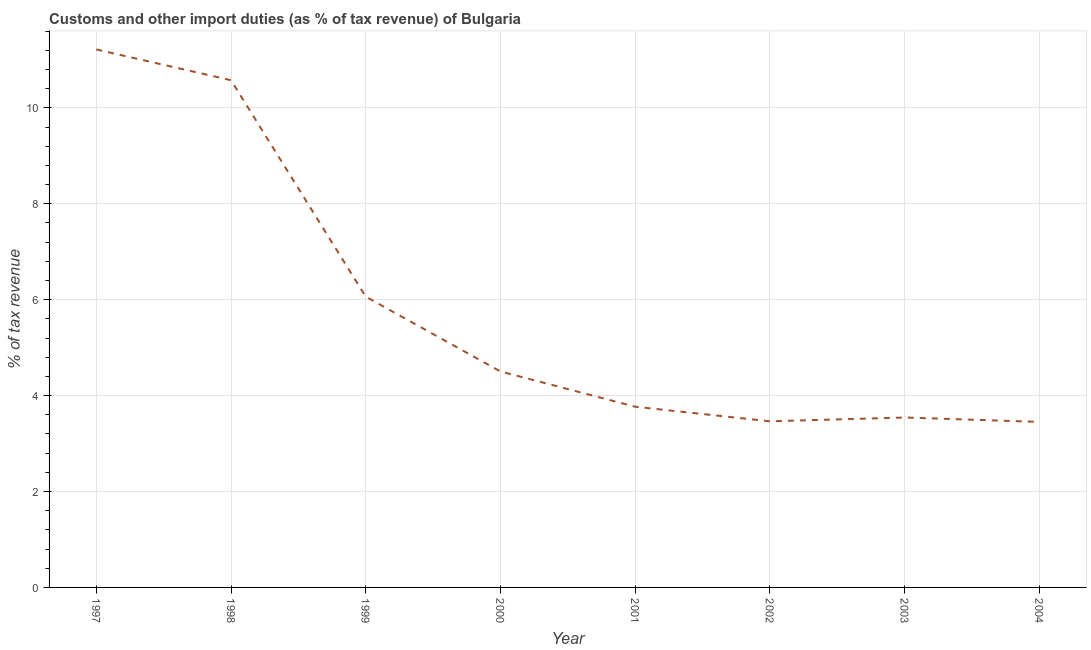What is the customs and other import duties in 2002?
Give a very brief answer. 3.46. Across all years, what is the maximum customs and other import duties?
Your response must be concise. 11.22. Across all years, what is the minimum customs and other import duties?
Your answer should be very brief. 3.45. In which year was the customs and other import duties maximum?
Your answer should be very brief. 1997. What is the sum of the customs and other import duties?
Give a very brief answer. 46.59. What is the difference between the customs and other import duties in 1997 and 2000?
Give a very brief answer. 6.71. What is the average customs and other import duties per year?
Provide a short and direct response. 5.82. What is the median customs and other import duties?
Provide a short and direct response. 4.14. In how many years, is the customs and other import duties greater than 10.8 %?
Offer a terse response. 1. Do a majority of the years between 1999 and 1997 (inclusive) have customs and other import duties greater than 2.4 %?
Make the answer very short. No. What is the ratio of the customs and other import duties in 1997 to that in 2002?
Provide a short and direct response. 3.24. Is the customs and other import duties in 1999 less than that in 2000?
Your answer should be compact. No. What is the difference between the highest and the second highest customs and other import duties?
Keep it short and to the point. 0.64. Is the sum of the customs and other import duties in 2001 and 2002 greater than the maximum customs and other import duties across all years?
Offer a terse response. No. What is the difference between the highest and the lowest customs and other import duties?
Your response must be concise. 7.77. Does the customs and other import duties monotonically increase over the years?
Provide a short and direct response. No. How many lines are there?
Your answer should be compact. 1. Are the values on the major ticks of Y-axis written in scientific E-notation?
Ensure brevity in your answer.  No. Does the graph contain grids?
Give a very brief answer. Yes. What is the title of the graph?
Offer a very short reply. Customs and other import duties (as % of tax revenue) of Bulgaria. What is the label or title of the X-axis?
Your answer should be compact. Year. What is the label or title of the Y-axis?
Your answer should be very brief. % of tax revenue. What is the % of tax revenue of 1997?
Offer a very short reply. 11.22. What is the % of tax revenue of 1998?
Give a very brief answer. 10.58. What is the % of tax revenue in 1999?
Make the answer very short. 6.06. What is the % of tax revenue in 2000?
Provide a short and direct response. 4.5. What is the % of tax revenue of 2001?
Provide a succinct answer. 3.77. What is the % of tax revenue of 2002?
Your answer should be very brief. 3.46. What is the % of tax revenue in 2003?
Make the answer very short. 3.54. What is the % of tax revenue in 2004?
Provide a succinct answer. 3.45. What is the difference between the % of tax revenue in 1997 and 1998?
Keep it short and to the point. 0.64. What is the difference between the % of tax revenue in 1997 and 1999?
Your answer should be compact. 5.16. What is the difference between the % of tax revenue in 1997 and 2000?
Offer a very short reply. 6.71. What is the difference between the % of tax revenue in 1997 and 2001?
Ensure brevity in your answer.  7.45. What is the difference between the % of tax revenue in 1997 and 2002?
Your response must be concise. 7.75. What is the difference between the % of tax revenue in 1997 and 2003?
Your answer should be very brief. 7.67. What is the difference between the % of tax revenue in 1997 and 2004?
Your answer should be compact. 7.77. What is the difference between the % of tax revenue in 1998 and 1999?
Offer a terse response. 4.51. What is the difference between the % of tax revenue in 1998 and 2000?
Provide a succinct answer. 6.07. What is the difference between the % of tax revenue in 1998 and 2001?
Give a very brief answer. 6.81. What is the difference between the % of tax revenue in 1998 and 2002?
Your response must be concise. 7.11. What is the difference between the % of tax revenue in 1998 and 2003?
Offer a terse response. 7.03. What is the difference between the % of tax revenue in 1998 and 2004?
Your answer should be very brief. 7.12. What is the difference between the % of tax revenue in 1999 and 2000?
Offer a very short reply. 1.56. What is the difference between the % of tax revenue in 1999 and 2001?
Provide a short and direct response. 2.29. What is the difference between the % of tax revenue in 1999 and 2002?
Keep it short and to the point. 2.6. What is the difference between the % of tax revenue in 1999 and 2003?
Offer a terse response. 2.52. What is the difference between the % of tax revenue in 1999 and 2004?
Make the answer very short. 2.61. What is the difference between the % of tax revenue in 2000 and 2001?
Provide a succinct answer. 0.74. What is the difference between the % of tax revenue in 2000 and 2002?
Offer a terse response. 1.04. What is the difference between the % of tax revenue in 2000 and 2003?
Offer a terse response. 0.96. What is the difference between the % of tax revenue in 2000 and 2004?
Keep it short and to the point. 1.05. What is the difference between the % of tax revenue in 2001 and 2002?
Your answer should be compact. 0.3. What is the difference between the % of tax revenue in 2001 and 2003?
Provide a succinct answer. 0.23. What is the difference between the % of tax revenue in 2001 and 2004?
Provide a short and direct response. 0.32. What is the difference between the % of tax revenue in 2002 and 2003?
Provide a succinct answer. -0.08. What is the difference between the % of tax revenue in 2002 and 2004?
Your answer should be compact. 0.01. What is the difference between the % of tax revenue in 2003 and 2004?
Give a very brief answer. 0.09. What is the ratio of the % of tax revenue in 1997 to that in 1998?
Offer a terse response. 1.06. What is the ratio of the % of tax revenue in 1997 to that in 1999?
Provide a short and direct response. 1.85. What is the ratio of the % of tax revenue in 1997 to that in 2000?
Keep it short and to the point. 2.49. What is the ratio of the % of tax revenue in 1997 to that in 2001?
Provide a short and direct response. 2.98. What is the ratio of the % of tax revenue in 1997 to that in 2002?
Provide a succinct answer. 3.24. What is the ratio of the % of tax revenue in 1997 to that in 2003?
Your response must be concise. 3.17. What is the ratio of the % of tax revenue in 1998 to that in 1999?
Provide a short and direct response. 1.74. What is the ratio of the % of tax revenue in 1998 to that in 2000?
Keep it short and to the point. 2.35. What is the ratio of the % of tax revenue in 1998 to that in 2001?
Provide a succinct answer. 2.81. What is the ratio of the % of tax revenue in 1998 to that in 2002?
Give a very brief answer. 3.05. What is the ratio of the % of tax revenue in 1998 to that in 2003?
Provide a short and direct response. 2.98. What is the ratio of the % of tax revenue in 1998 to that in 2004?
Provide a short and direct response. 3.06. What is the ratio of the % of tax revenue in 1999 to that in 2000?
Ensure brevity in your answer.  1.35. What is the ratio of the % of tax revenue in 1999 to that in 2001?
Provide a short and direct response. 1.61. What is the ratio of the % of tax revenue in 1999 to that in 2003?
Ensure brevity in your answer.  1.71. What is the ratio of the % of tax revenue in 1999 to that in 2004?
Ensure brevity in your answer.  1.76. What is the ratio of the % of tax revenue in 2000 to that in 2001?
Provide a succinct answer. 1.2. What is the ratio of the % of tax revenue in 2000 to that in 2002?
Offer a very short reply. 1.3. What is the ratio of the % of tax revenue in 2000 to that in 2003?
Provide a short and direct response. 1.27. What is the ratio of the % of tax revenue in 2000 to that in 2004?
Ensure brevity in your answer.  1.3. What is the ratio of the % of tax revenue in 2001 to that in 2002?
Your answer should be very brief. 1.09. What is the ratio of the % of tax revenue in 2001 to that in 2003?
Offer a very short reply. 1.06. What is the ratio of the % of tax revenue in 2001 to that in 2004?
Offer a terse response. 1.09. What is the ratio of the % of tax revenue in 2002 to that in 2004?
Offer a very short reply. 1. 